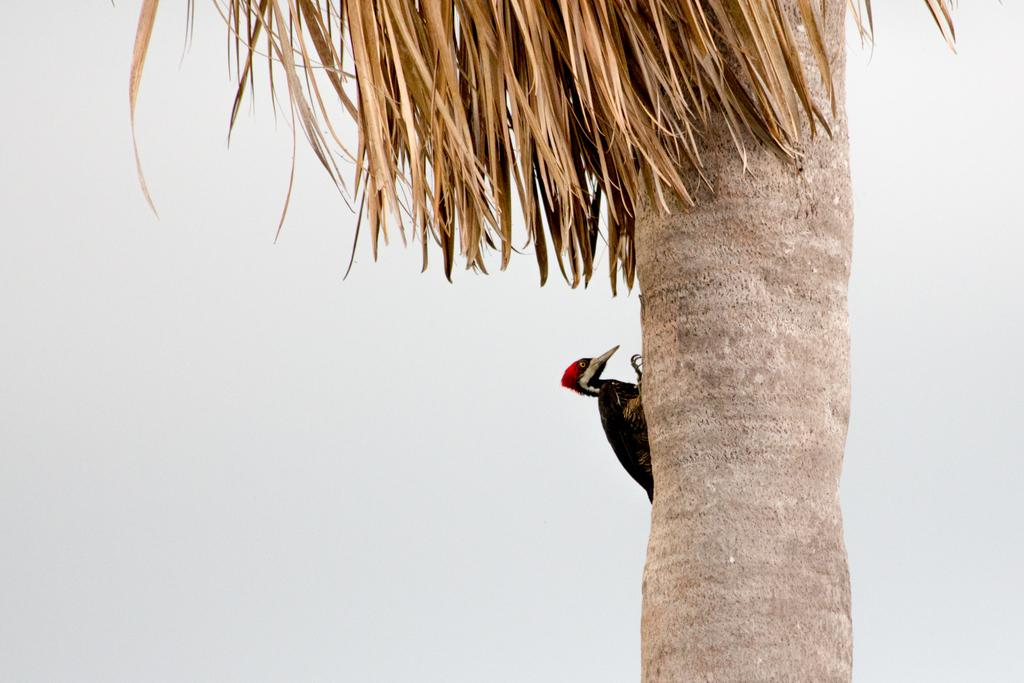What type of animal can be seen in the image? There is a bird in the image. Where is the bird located? The bird is on a tree. What is visible in the background of the image? Sky is visible in the image. What can be seen in the sky? Clouds are present in the sky. What type of star can be seen on the bird's face in the image? There is no star present on the bird's face in the image, and the bird does not have a face. 